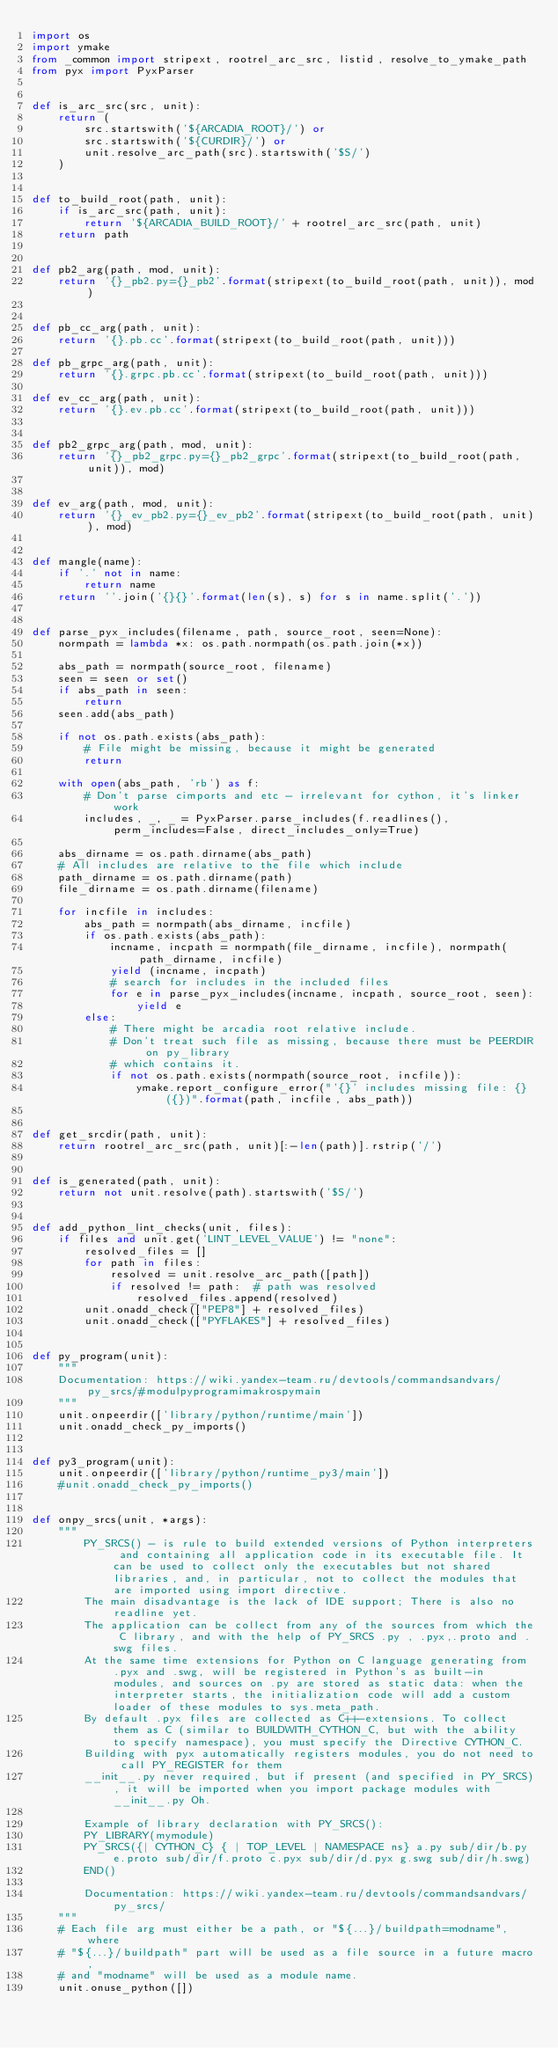<code> <loc_0><loc_0><loc_500><loc_500><_Python_>import os
import ymake
from _common import stripext, rootrel_arc_src, listid, resolve_to_ymake_path
from pyx import PyxParser


def is_arc_src(src, unit):
    return (
        src.startswith('${ARCADIA_ROOT}/') or
        src.startswith('${CURDIR}/') or
        unit.resolve_arc_path(src).startswith('$S/')
    )


def to_build_root(path, unit):
    if is_arc_src(path, unit):
        return '${ARCADIA_BUILD_ROOT}/' + rootrel_arc_src(path, unit)
    return path


def pb2_arg(path, mod, unit):
    return '{}_pb2.py={}_pb2'.format(stripext(to_build_root(path, unit)), mod)


def pb_cc_arg(path, unit):
    return '{}.pb.cc'.format(stripext(to_build_root(path, unit)))

def pb_grpc_arg(path, unit):
    return '{}.grpc.pb.cc'.format(stripext(to_build_root(path, unit)))

def ev_cc_arg(path, unit):
    return '{}.ev.pb.cc'.format(stripext(to_build_root(path, unit)))


def pb2_grpc_arg(path, mod, unit):
    return '{}_pb2_grpc.py={}_pb2_grpc'.format(stripext(to_build_root(path, unit)), mod)


def ev_arg(path, mod, unit):
    return '{}_ev_pb2.py={}_ev_pb2'.format(stripext(to_build_root(path, unit)), mod)


def mangle(name):
    if '.' not in name:
        return name
    return ''.join('{}{}'.format(len(s), s) for s in name.split('.'))


def parse_pyx_includes(filename, path, source_root, seen=None):
    normpath = lambda *x: os.path.normpath(os.path.join(*x))

    abs_path = normpath(source_root, filename)
    seen = seen or set()
    if abs_path in seen:
        return
    seen.add(abs_path)

    if not os.path.exists(abs_path):
        # File might be missing, because it might be generated
        return

    with open(abs_path, 'rb') as f:
        # Don't parse cimports and etc - irrelevant for cython, it's linker work
        includes, _, _ = PyxParser.parse_includes(f.readlines(), perm_includes=False, direct_includes_only=True)

    abs_dirname = os.path.dirname(abs_path)
    # All includes are relative to the file which include
    path_dirname = os.path.dirname(path)
    file_dirname = os.path.dirname(filename)

    for incfile in includes:
        abs_path = normpath(abs_dirname, incfile)
        if os.path.exists(abs_path):
            incname, incpath = normpath(file_dirname, incfile), normpath(path_dirname, incfile)
            yield (incname, incpath)
            # search for includes in the included files
            for e in parse_pyx_includes(incname, incpath, source_root, seen):
                yield e
        else:
            # There might be arcadia root relative include.
            # Don't treat such file as missing, because there must be PEERDIR on py_library
            # which contains it.
            if not os.path.exists(normpath(source_root, incfile)):
                ymake.report_configure_error("'{}' includes missing file: {} ({})".format(path, incfile, abs_path))


def get_srcdir(path, unit):
    return rootrel_arc_src(path, unit)[:-len(path)].rstrip('/')


def is_generated(path, unit):
    return not unit.resolve(path).startswith('$S/')


def add_python_lint_checks(unit, files):
    if files and unit.get('LINT_LEVEL_VALUE') != "none":
        resolved_files = []
        for path in files:
            resolved = unit.resolve_arc_path([path])
            if resolved != path:  # path was resolved
                resolved_files.append(resolved)
        unit.onadd_check(["PEP8"] + resolved_files)
        unit.onadd_check(["PYFLAKES"] + resolved_files)


def py_program(unit):
    """
    Documentation: https://wiki.yandex-team.ru/devtools/commandsandvars/py_srcs/#modulpyprogramimakrospymain
    """
    unit.onpeerdir(['library/python/runtime/main'])
    unit.onadd_check_py_imports()


def py3_program(unit):
    unit.onpeerdir(['library/python/runtime_py3/main'])
    #unit.onadd_check_py_imports()


def onpy_srcs(unit, *args):
    """
        PY_SRCS() - is rule to build extended versions of Python interpreters and containing all application code in its executable file. It can be used to collect only the executables but not shared libraries, and, in particular, not to collect the modules that are imported using import directive.
        The main disadvantage is the lack of IDE support; There is also no readline yet.
        The application can be collect from any of the sources from which the C library, and with the help of PY_SRCS .py , .pyx,.proto and .swg files.
        At the same time extensions for Python on C language generating from .pyx and .swg, will be registered in Python's as built-in modules, and sources on .py are stored as static data: when the interpreter starts, the initialization code will add a custom loader of these modules to sys.meta_path.
        By default .pyx files are collected as C++-extensions. To collect them as C (similar to BUILDWITH_CYTHON_C, but with the ability to specify namespace), you must specify the Directive CYTHON_C.
        Building with pyx automatically registers modules, you do not need to call PY_REGISTER for them
        __init__.py never required, but if present (and specified in PY_SRCS), it will be imported when you import package modules with __init__.py Oh.

        Example of library declaration with PY_SRCS():
        PY_LIBRARY(mymodule)
        PY_SRCS({| CYTHON_C} { | TOP_LEVEL | NAMESPACE ns} a.py sub/dir/b.py e.proto sub/dir/f.proto c.pyx sub/dir/d.pyx g.swg sub/dir/h.swg)
        END()

        Documentation: https://wiki.yandex-team.ru/devtools/commandsandvars/py_srcs/
    """
    # Each file arg must either be a path, or "${...}/buildpath=modname", where
    # "${...}/buildpath" part will be used as a file source in a future macro,
    # and "modname" will be used as a module name.
    unit.onuse_python([])
</code> 